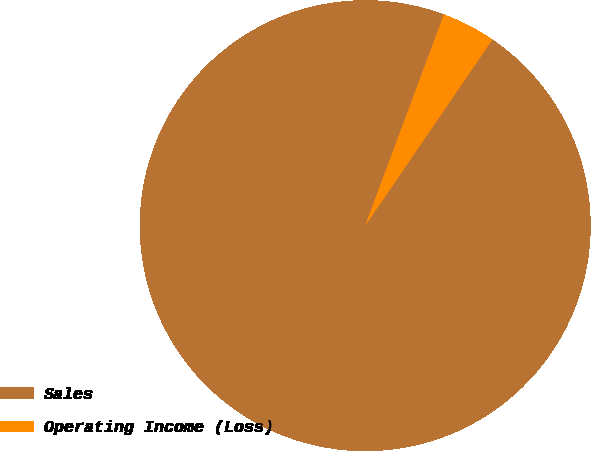Convert chart. <chart><loc_0><loc_0><loc_500><loc_500><pie_chart><fcel>Sales<fcel>Operating Income (Loss)<nl><fcel>96.14%<fcel>3.86%<nl></chart> 